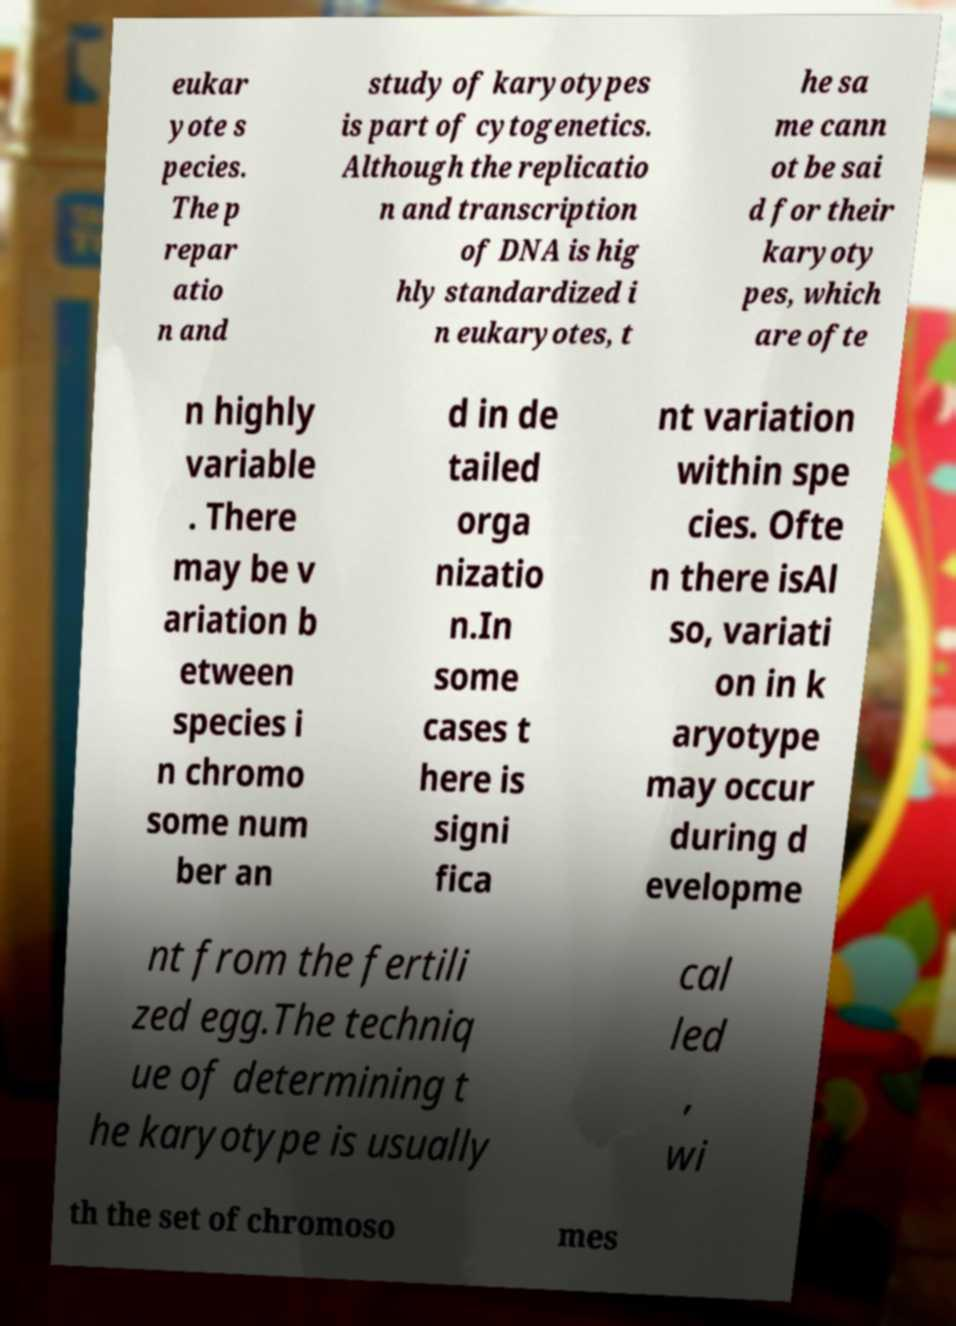I need the written content from this picture converted into text. Can you do that? eukar yote s pecies. The p repar atio n and study of karyotypes is part of cytogenetics. Although the replicatio n and transcription of DNA is hig hly standardized i n eukaryotes, t he sa me cann ot be sai d for their karyoty pes, which are ofte n highly variable . There may be v ariation b etween species i n chromo some num ber an d in de tailed orga nizatio n.In some cases t here is signi fica nt variation within spe cies. Ofte n there isAl so, variati on in k aryotype may occur during d evelopme nt from the fertili zed egg.The techniq ue of determining t he karyotype is usually cal led , wi th the set of chromoso mes 